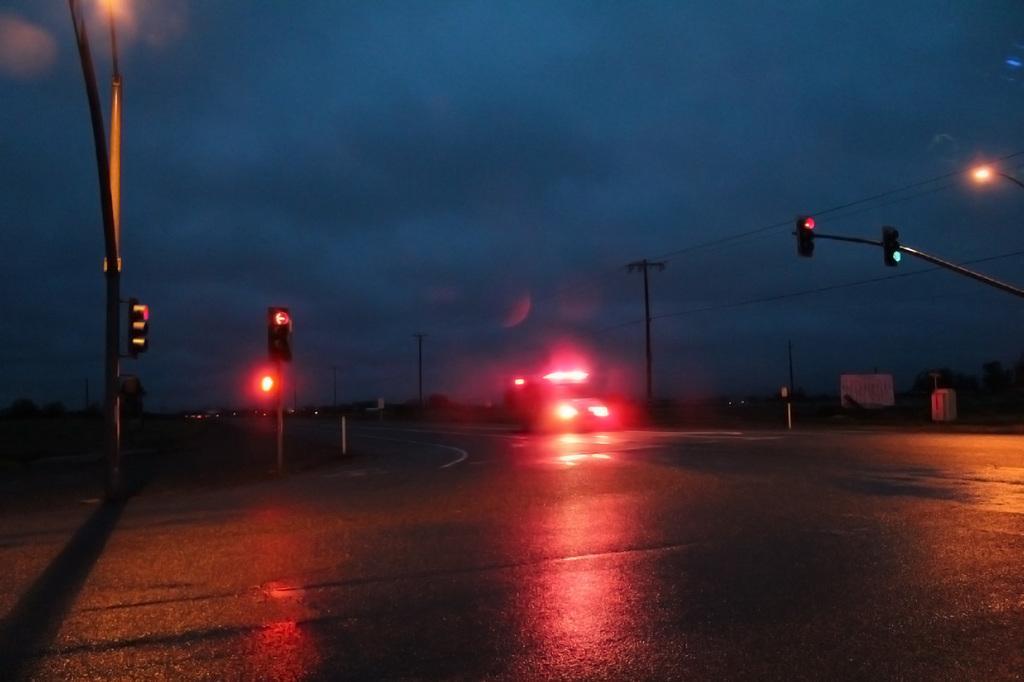Can you describe this image briefly? This picture is taken during night, in the picture there is a road, on the road there is a vehicle, beside the road there are traffic signal lights, power poles and power line cables visible , at the top there is the sky. 